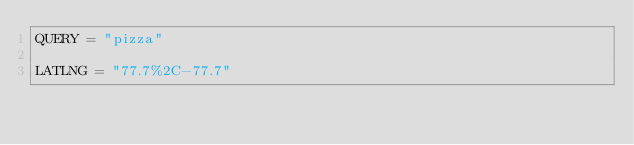<code> <loc_0><loc_0><loc_500><loc_500><_Ruby_>QUERY = "pizza"

LATLNG = "77.7%2C-77.7" 

</code> 